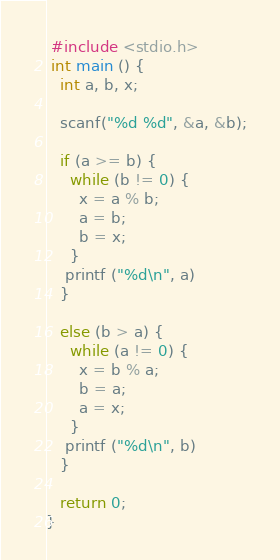Convert code to text. <code><loc_0><loc_0><loc_500><loc_500><_C_> #include <stdio.h>
 int main () {
   int a, b, x;

   scanf("%d %d", &a, &b);

   if (a >= b) {
     while (b != 0) {
       x = a % b;
       a = b;
       b = x;
     }
    printf ("%d\n", a)
   }

   else (b > a) {
     while (a != 0) {
       x = b % a;
       b = a;
       a = x;
     }
    printf ("%d\n", b)
   }

   return 0;
}</code> 